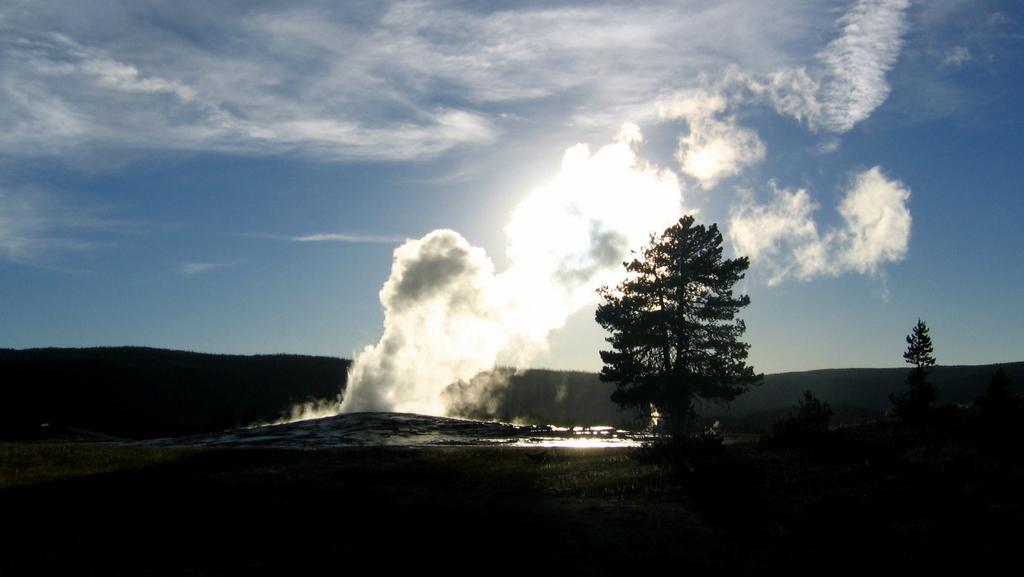Could you give a brief overview of what you see in this image? Here there is a small mountain from which smoke is coming out. Beside there is a tree and behind we can see some mountains. 